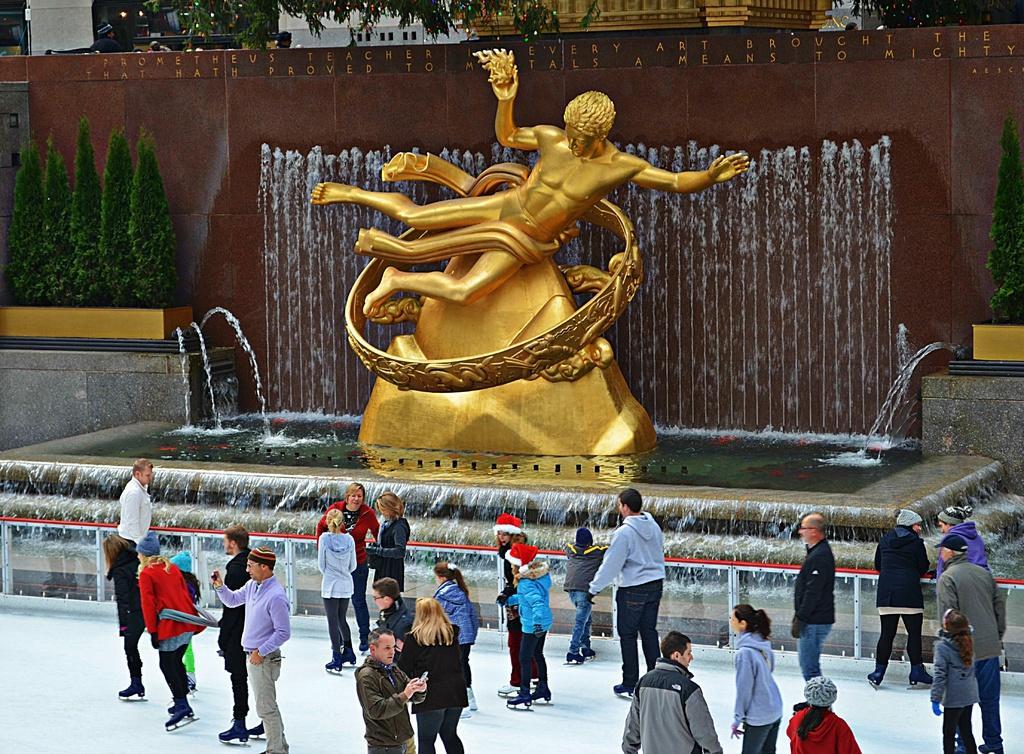Can you describe this image briefly? In this picture we can see golden color statue, beside the fountain and water. At the bottom we can see the group of persons standing on the snow. At the top we can see the trees, buildings and lights. On the left we can see trees near to the wall. 